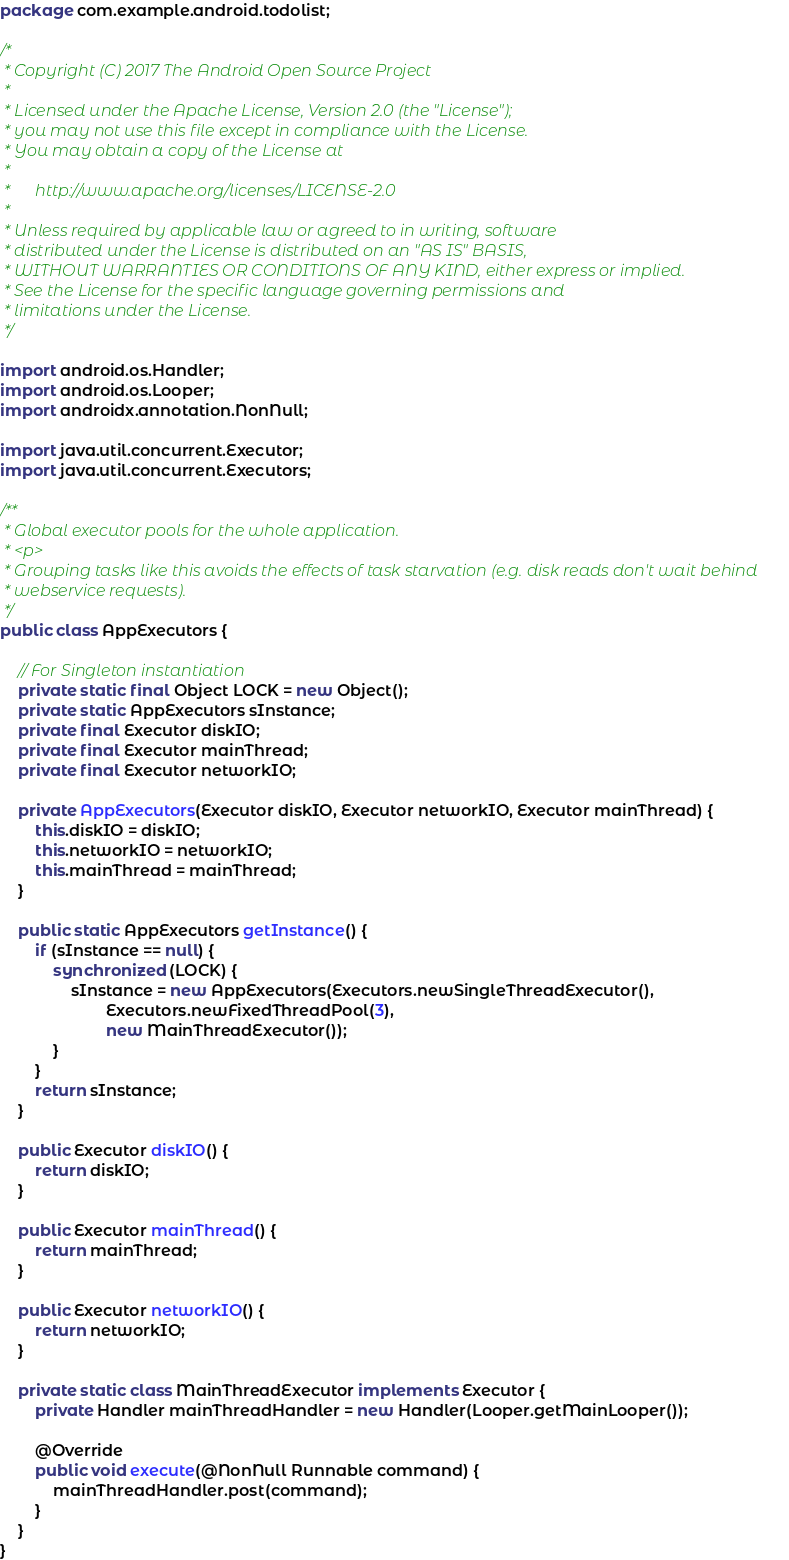Convert code to text. <code><loc_0><loc_0><loc_500><loc_500><_Java_>package com.example.android.todolist;

/*
 * Copyright (C) 2017 The Android Open Source Project
 *
 * Licensed under the Apache License, Version 2.0 (the "License");
 * you may not use this file except in compliance with the License.
 * You may obtain a copy of the License at
 *
 *      http://www.apache.org/licenses/LICENSE-2.0
 *
 * Unless required by applicable law or agreed to in writing, software
 * distributed under the License is distributed on an "AS IS" BASIS,
 * WITHOUT WARRANTIES OR CONDITIONS OF ANY KIND, either express or implied.
 * See the License for the specific language governing permissions and
 * limitations under the License.
 */

import android.os.Handler;
import android.os.Looper;
import androidx.annotation.NonNull;

import java.util.concurrent.Executor;
import java.util.concurrent.Executors;

/**
 * Global executor pools for the whole application.
 * <p>
 * Grouping tasks like this avoids the effects of task starvation (e.g. disk reads don't wait behind
 * webservice requests).
 */
public class AppExecutors {

    // For Singleton instantiation
    private static final Object LOCK = new Object();
    private static AppExecutors sInstance;
    private final Executor diskIO;
    private final Executor mainThread;
    private final Executor networkIO;

    private AppExecutors(Executor diskIO, Executor networkIO, Executor mainThread) {
        this.diskIO = diskIO;
        this.networkIO = networkIO;
        this.mainThread = mainThread;
    }

    public static AppExecutors getInstance() {
        if (sInstance == null) {
            synchronized (LOCK) {
                sInstance = new AppExecutors(Executors.newSingleThreadExecutor(),
                        Executors.newFixedThreadPool(3),
                        new MainThreadExecutor());
            }
        }
        return sInstance;
    }

    public Executor diskIO() {
        return diskIO;
    }

    public Executor mainThread() {
        return mainThread;
    }

    public Executor networkIO() {
        return networkIO;
    }

    private static class MainThreadExecutor implements Executor {
        private Handler mainThreadHandler = new Handler(Looper.getMainLooper());

        @Override
        public void execute(@NonNull Runnable command) {
            mainThreadHandler.post(command);
        }
    }
}
</code> 